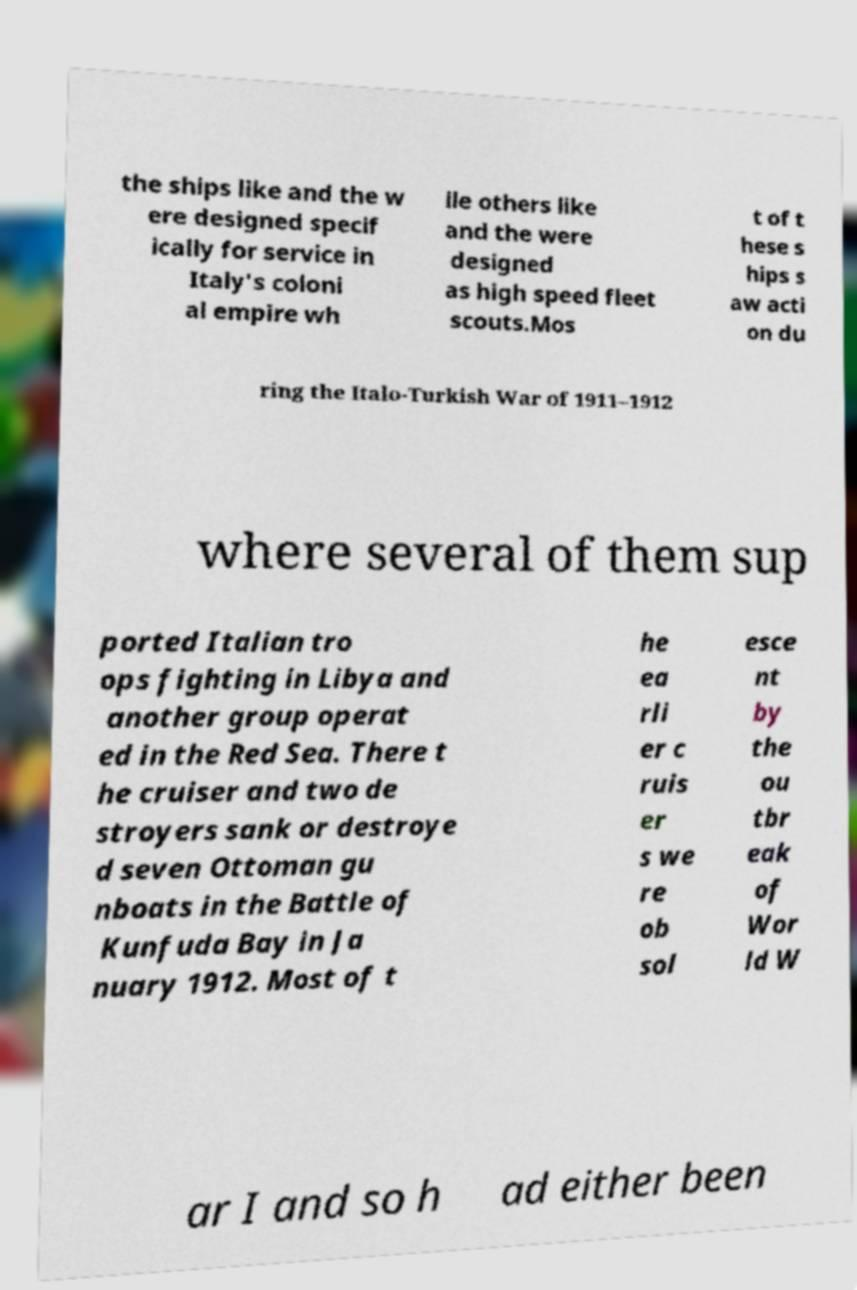For documentation purposes, I need the text within this image transcribed. Could you provide that? the ships like and the w ere designed specif ically for service in Italy's coloni al empire wh ile others like and the were designed as high speed fleet scouts.Mos t of t hese s hips s aw acti on du ring the Italo-Turkish War of 1911–1912 where several of them sup ported Italian tro ops fighting in Libya and another group operat ed in the Red Sea. There t he cruiser and two de stroyers sank or destroye d seven Ottoman gu nboats in the Battle of Kunfuda Bay in Ja nuary 1912. Most of t he ea rli er c ruis er s we re ob sol esce nt by the ou tbr eak of Wor ld W ar I and so h ad either been 